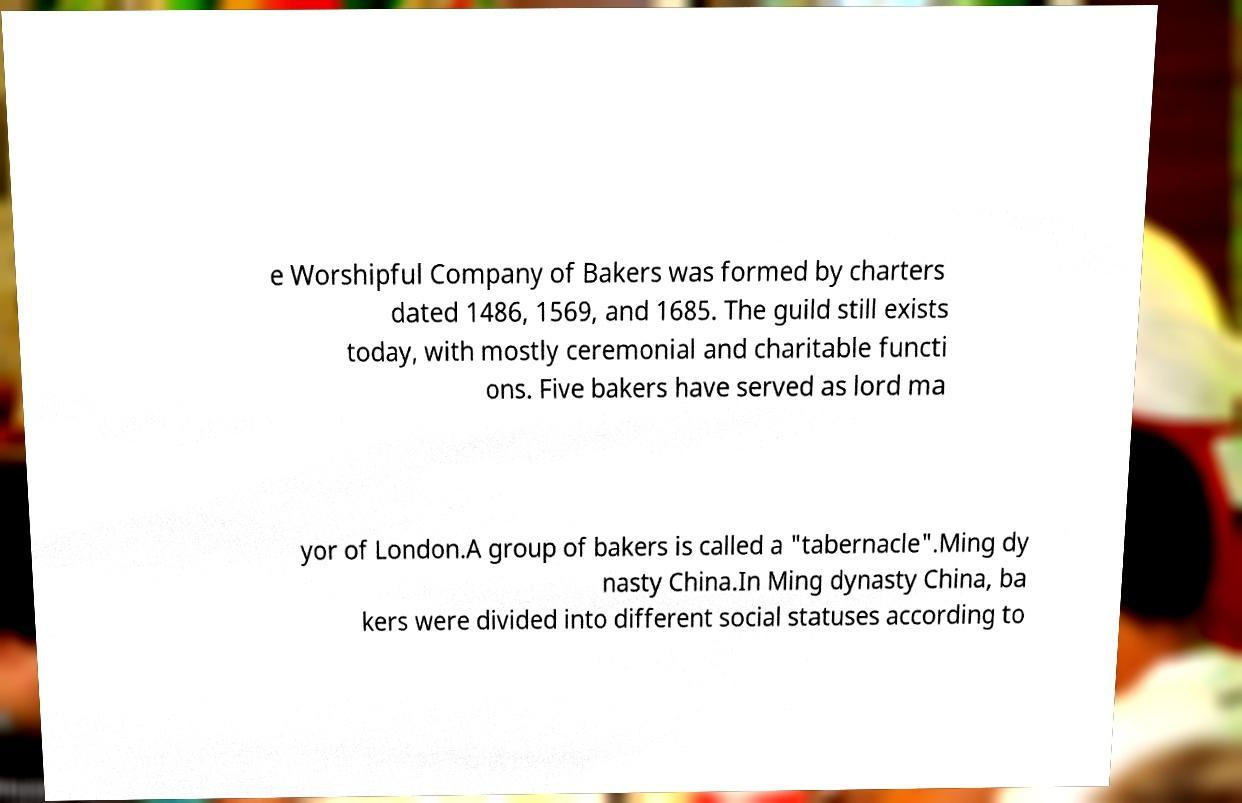There's text embedded in this image that I need extracted. Can you transcribe it verbatim? e Worshipful Company of Bakers was formed by charters dated 1486, 1569, and 1685. The guild still exists today, with mostly ceremonial and charitable functi ons. Five bakers have served as lord ma yor of London.A group of bakers is called a "tabernacle".Ming dy nasty China.In Ming dynasty China, ba kers were divided into different social statuses according to 